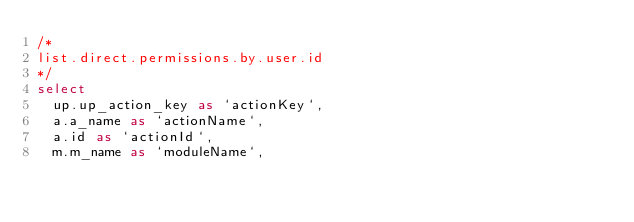Convert code to text. <code><loc_0><loc_0><loc_500><loc_500><_SQL_>/*
list.direct.permissions.by.user.id 
*/
select
	up.up_action_key as `actionKey`,
	a.a_name as `actionName`,
	a.id as `actionId`,
	m.m_name as `moduleName`,</code> 